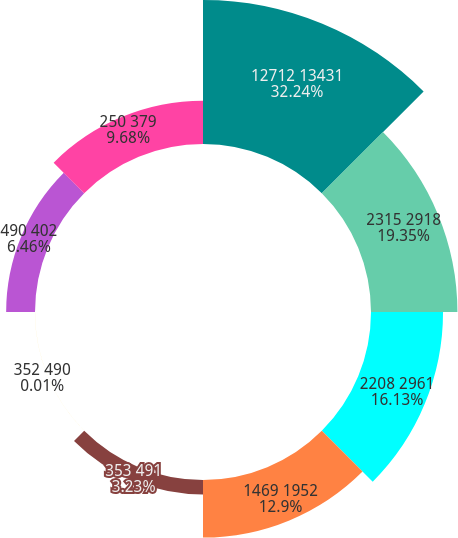Convert chart. <chart><loc_0><loc_0><loc_500><loc_500><pie_chart><fcel>12712 13431<fcel>2315 2918<fcel>2208 2961<fcel>1469 1952<fcel>353 491<fcel>352 490<fcel>490 402<fcel>250 379<nl><fcel>32.24%<fcel>19.35%<fcel>16.13%<fcel>12.9%<fcel>3.23%<fcel>0.01%<fcel>6.46%<fcel>9.68%<nl></chart> 